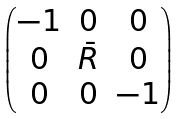<formula> <loc_0><loc_0><loc_500><loc_500>\begin{pmatrix} - 1 & 0 & 0 \\ 0 & \bar { R } & 0 \\ 0 & 0 & - 1 \\ \end{pmatrix}</formula> 